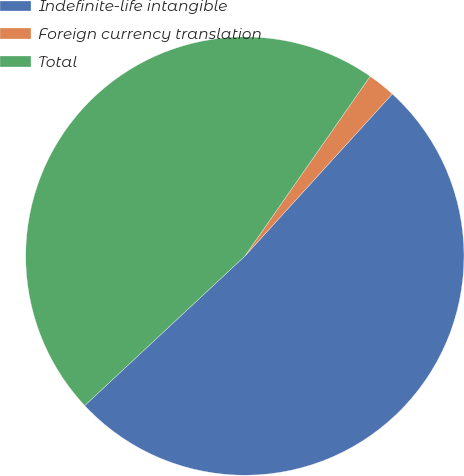Convert chart to OTSL. <chart><loc_0><loc_0><loc_500><loc_500><pie_chart><fcel>Indefinite-life intangible<fcel>Foreign currency translation<fcel>Total<nl><fcel>51.3%<fcel>2.06%<fcel>46.64%<nl></chart> 